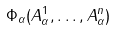<formula> <loc_0><loc_0><loc_500><loc_500>\Phi _ { \alpha } ( A _ { \alpha } ^ { 1 } , \dots , A _ { \alpha } ^ { n } )</formula> 